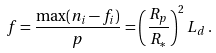<formula> <loc_0><loc_0><loc_500><loc_500>f = \frac { \max ( n _ { i } - f _ { i } ) } { p } = \left ( \frac { R _ { p } } { R _ { * } } \right ) ^ { 2 } L _ { d } \, .</formula> 